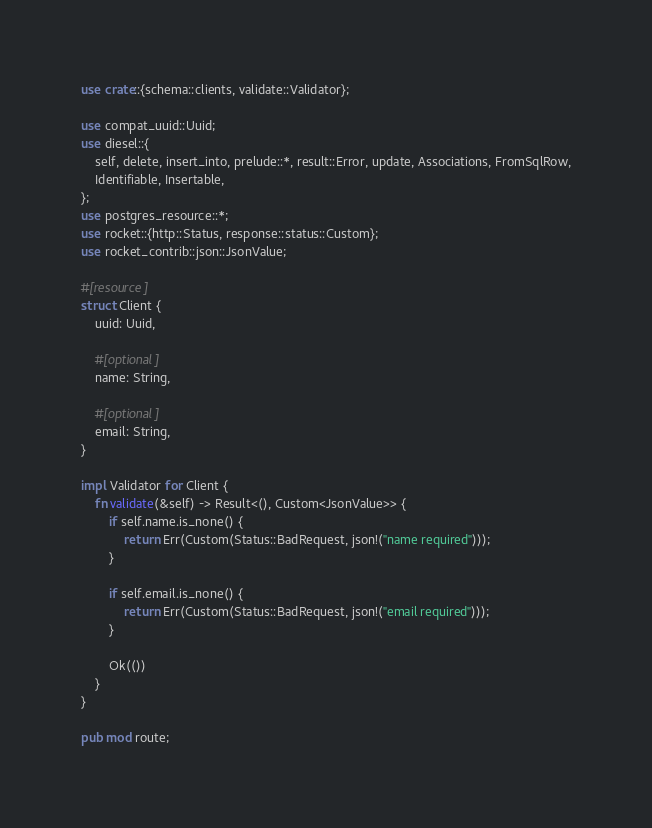Convert code to text. <code><loc_0><loc_0><loc_500><loc_500><_Rust_>use crate::{schema::clients, validate::Validator};

use compat_uuid::Uuid;
use diesel::{
    self, delete, insert_into, prelude::*, result::Error, update, Associations, FromSqlRow,
    Identifiable, Insertable,
};
use postgres_resource::*;
use rocket::{http::Status, response::status::Custom};
use rocket_contrib::json::JsonValue;

#[resource]
struct Client {
    uuid: Uuid,

    #[optional]
    name: String,

    #[optional]
    email: String,
}

impl Validator for Client {
    fn validate(&self) -> Result<(), Custom<JsonValue>> {
        if self.name.is_none() {
            return Err(Custom(Status::BadRequest, json!("name required")));
        }

        if self.email.is_none() {
            return Err(Custom(Status::BadRequest, json!("email required")));
        }

        Ok(())
    }
}

pub mod route;
</code> 